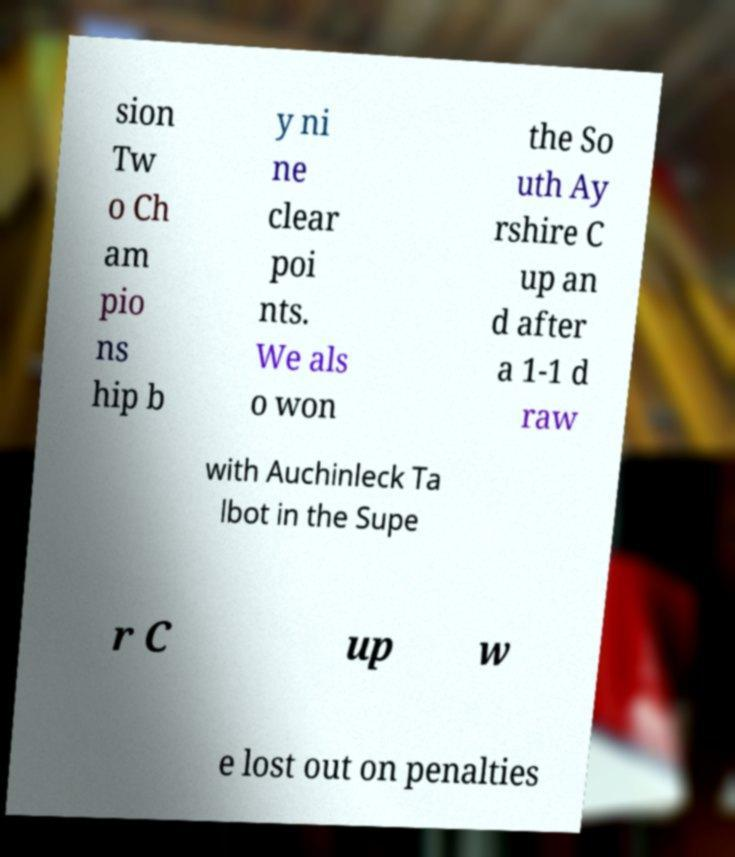There's text embedded in this image that I need extracted. Can you transcribe it verbatim? sion Tw o Ch am pio ns hip b y ni ne clear poi nts. We als o won the So uth Ay rshire C up an d after a 1-1 d raw with Auchinleck Ta lbot in the Supe r C up w e lost out on penalties 